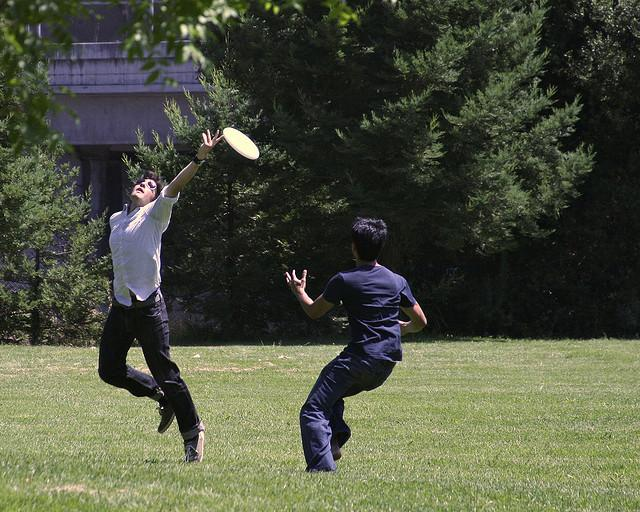The man in the white shirt is using what to touch the frisbee? Please explain your reasoning. fingertips. The man is jumping with his fingers outstretched. 